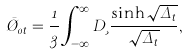Convert formula to latex. <formula><loc_0><loc_0><loc_500><loc_500>\bar { \chi } _ { 0 t } = \frac { 1 } { 3 } \int _ { - \infty } ^ { \infty } D \xi \frac { \sinh { \sqrt { \Delta _ { t } } } } { \sqrt { \Delta _ { t } } } ,</formula> 